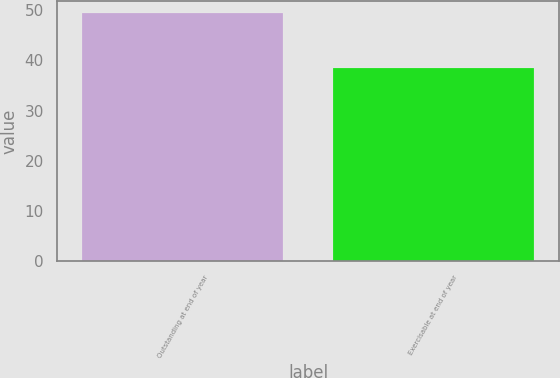Convert chart to OTSL. <chart><loc_0><loc_0><loc_500><loc_500><bar_chart><fcel>Outstanding at end of year<fcel>Exercisable at end of year<nl><fcel>49.4<fcel>38.45<nl></chart> 